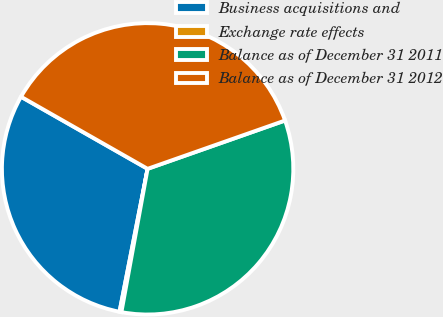<chart> <loc_0><loc_0><loc_500><loc_500><pie_chart><fcel>Business acquisitions and<fcel>Exchange rate effects<fcel>Balance as of December 31 2011<fcel>Balance as of December 31 2012<nl><fcel>30.15%<fcel>0.21%<fcel>33.26%<fcel>36.38%<nl></chart> 